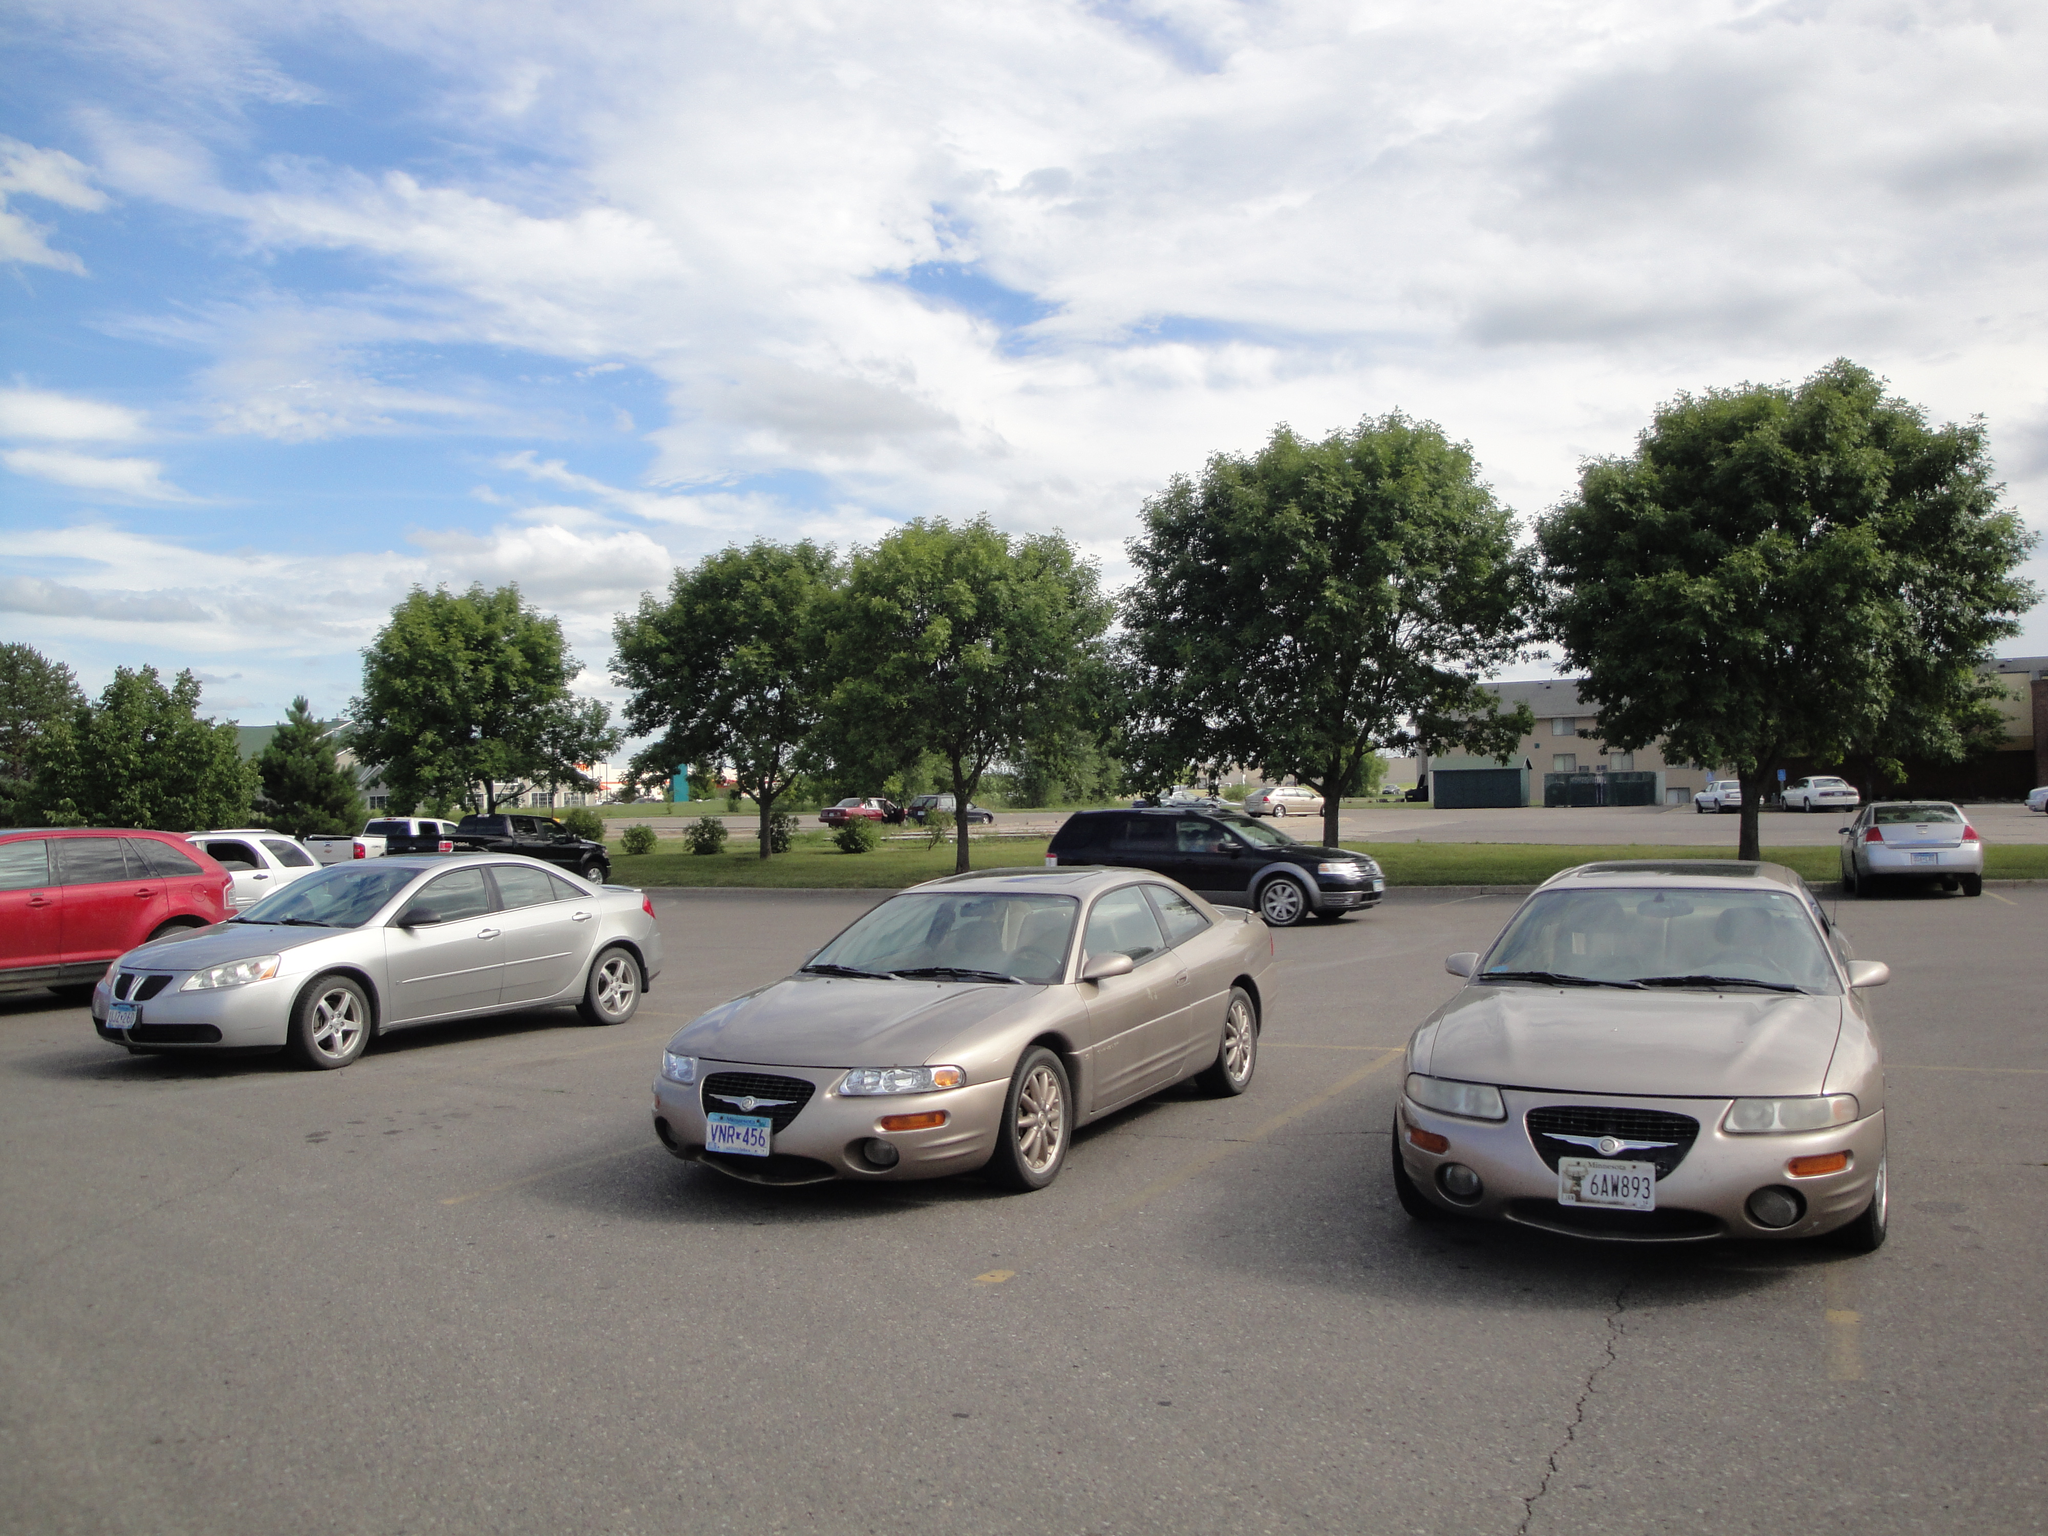Please provide a concise description of this image. In this image we can see group of vehicles parked on the ground. In the middle of the image we can see a group of trees and in the background, we can see a building and a cloudy sky. 